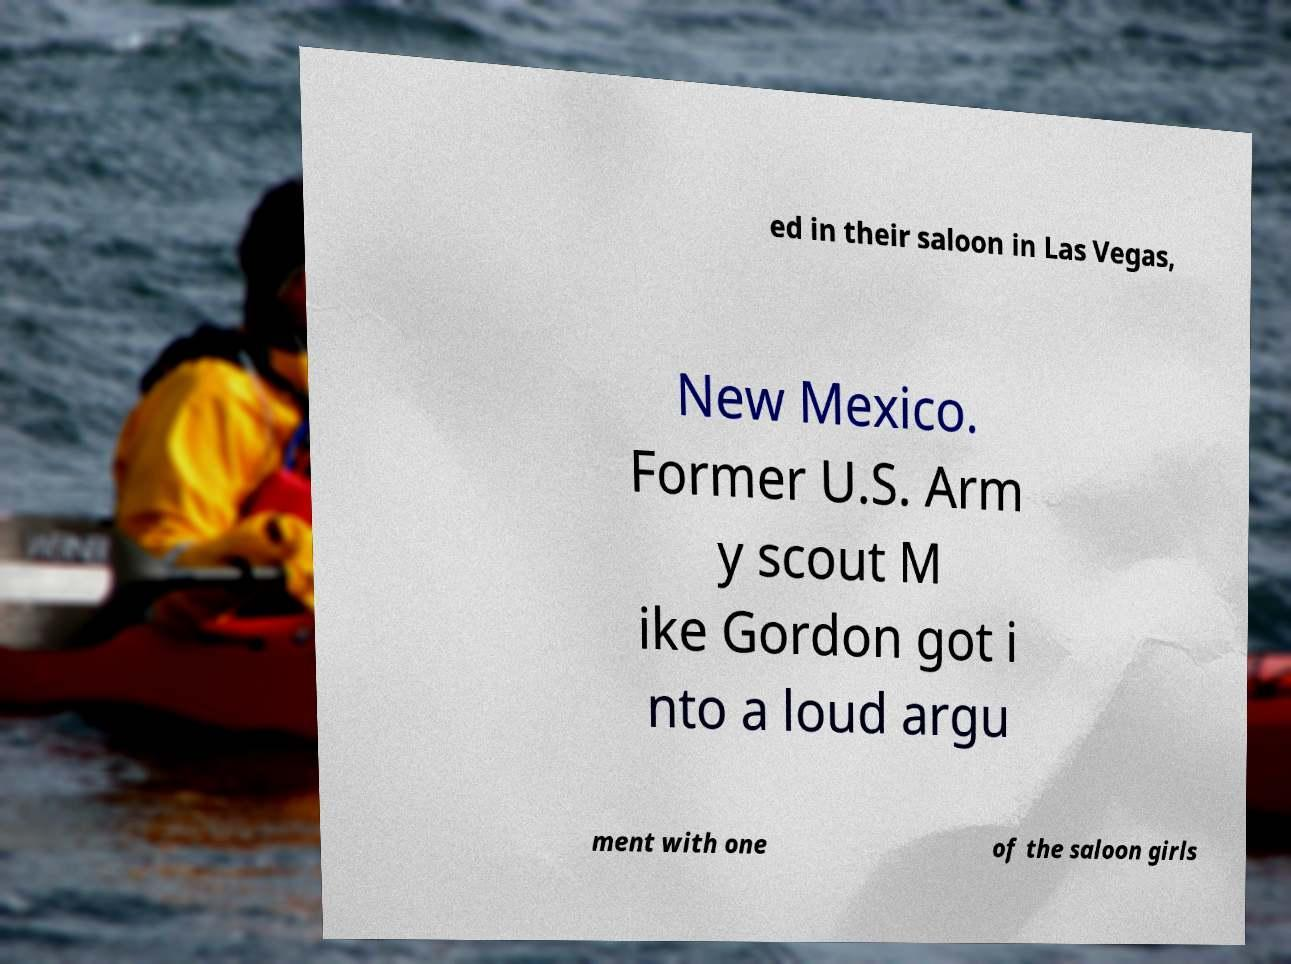I need the written content from this picture converted into text. Can you do that? ed in their saloon in Las Vegas, New Mexico. Former U.S. Arm y scout M ike Gordon got i nto a loud argu ment with one of the saloon girls 